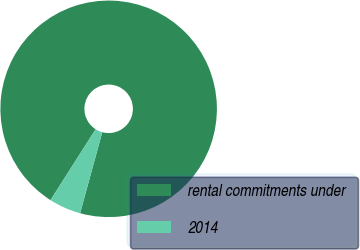Convert chart to OTSL. <chart><loc_0><loc_0><loc_500><loc_500><pie_chart><fcel>rental commitments under<fcel>2014<nl><fcel>95.22%<fcel>4.78%<nl></chart> 